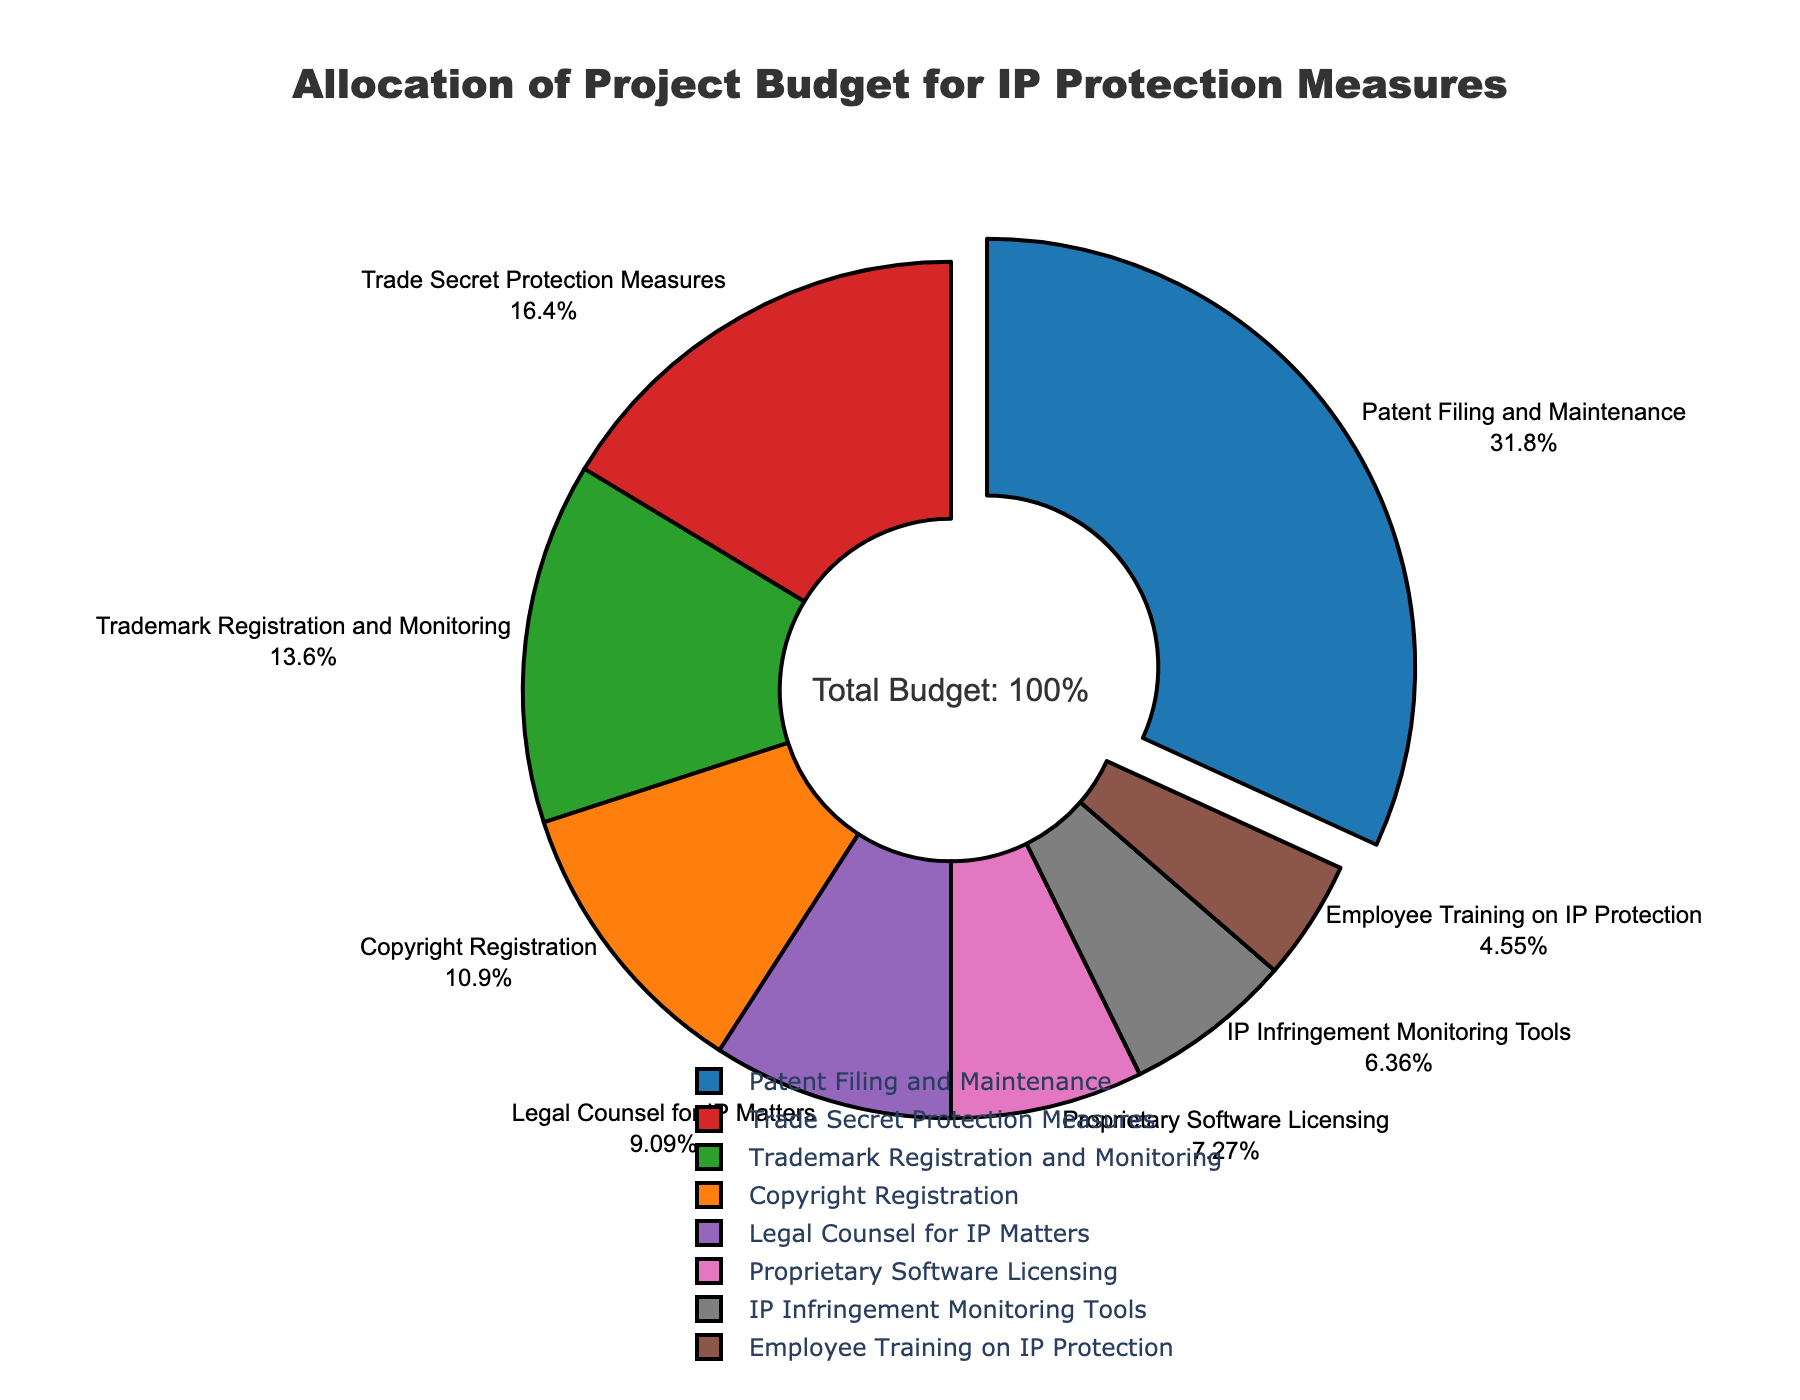What's the largest budget allocation measure in the pie chart? The largest budget allocation measure is identified by the largest slice, which in this case is "Patent Filing and Maintenance" at 35%.
Answer: Patent Filing and Maintenance Which measure receives the smallest allocation? The smallest allocation is determined by finding the smallest slice in the pie chart, which is "Employee Training on IP Protection" at 5%.
Answer: Employee Training on IP Protection What is the difference between the budget allocations for Patent Filing and Maintenance and for Legal Counsel for IP Matters? First, note that Patent Filing and Maintenance has 35% and Legal Counsel for IP Matters has 10%. The difference is calculated as 35% - 10% = 25%.
Answer: 25% Which measure has more budget allocation: Trade Secret Protection Measures or Proprietary Software Licensing? Trade Secret Protection Measures has 18% allocation, while Proprietary Software Licensing has 8%. Since 18% is greater than 8%, Trade Secret Protection Measures has more budget allocation.
Answer: Trade Secret Protection Measures What is the combined budget allocation for Copyright Registration and Trademark Registration and Monitoring? Add the budget allocations for Copyright Registration (12%) and Trademark Registration and Monitoring (15%). The combined allocation is 12% + 15% = 27%.
Answer: 27% Is the allocation for IP Infringement Monitoring Tools greater than Employee Training on IP Protection? IP Infringement Monitoring Tools has a 7% allocation, while Employee Training on IP Protection has 5%. Since 7% is greater than 5%, the allocation for IP Infringement Monitoring Tools is indeed greater.
Answer: Yes What proportion of the budget is allocated to measures other than Patent Filing and Maintenance? The total budget allocation is 100%. Subtract the allocation for Patent Filing and Maintenance (35%) from 100%, i.e., 100% - 35% = 65%.
Answer: 65% What is the average budget allocation for all the listed measures? To find the average, sum all the budget allocations (35% + 12% + 15% + 18% + 10% + 5% + 8% + 7% = 110%) and divide by the number of measures (8). The average is 110% / 8 = 13.75%.
Answer: 13.75% 